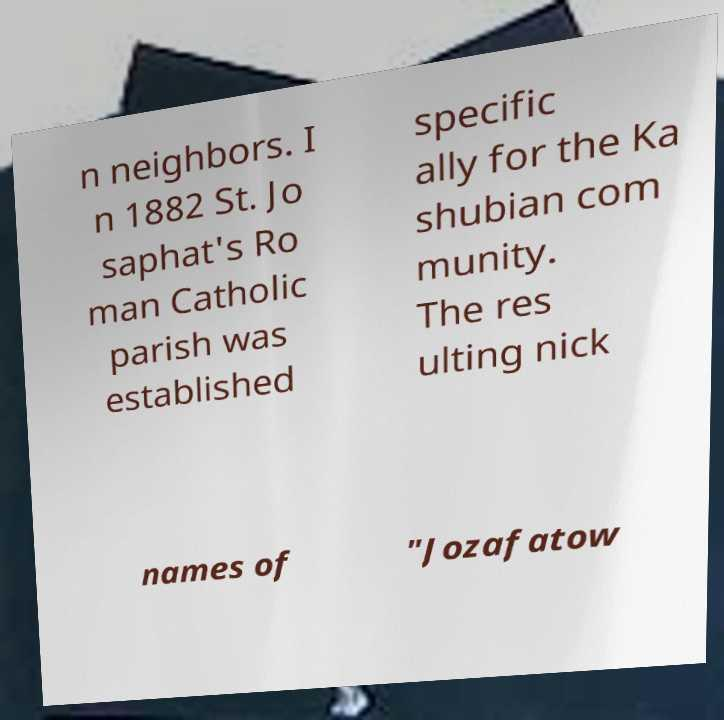For documentation purposes, I need the text within this image transcribed. Could you provide that? n neighbors. I n 1882 St. Jo saphat's Ro man Catholic parish was established specific ally for the Ka shubian com munity. The res ulting nick names of "Jozafatow 